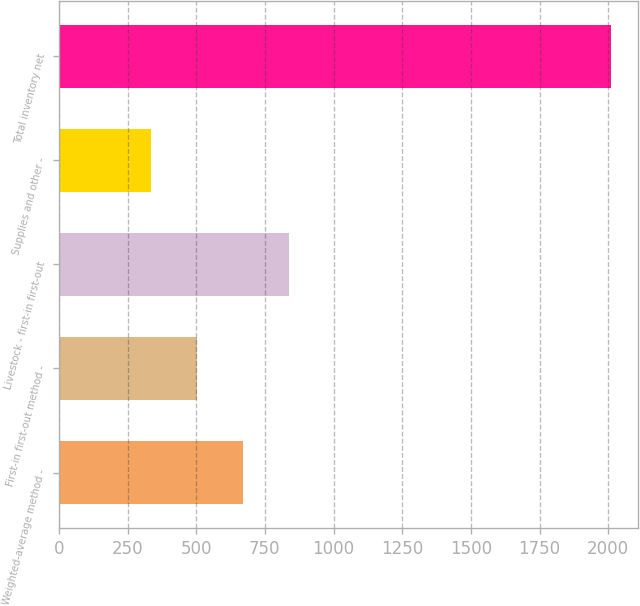Convert chart to OTSL. <chart><loc_0><loc_0><loc_500><loc_500><bar_chart><fcel>Weighted-average method -<fcel>First-in first-out method -<fcel>Livestock - first-in first-out<fcel>Supplies and other -<fcel>Total inventory net<nl><fcel>669.8<fcel>502.4<fcel>837.2<fcel>335<fcel>2009<nl></chart> 